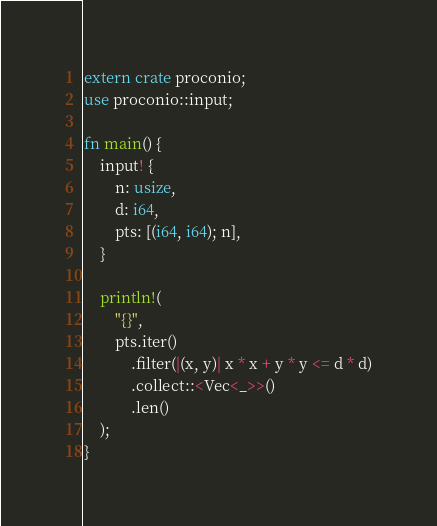<code> <loc_0><loc_0><loc_500><loc_500><_Rust_>extern crate proconio;
use proconio::input;

fn main() {
    input! {
        n: usize,
        d: i64,
        pts: [(i64, i64); n],
    }

    println!(
        "{}",
        pts.iter()
            .filter(|(x, y)| x * x + y * y <= d * d)
            .collect::<Vec<_>>()
            .len()
    );
}
</code> 